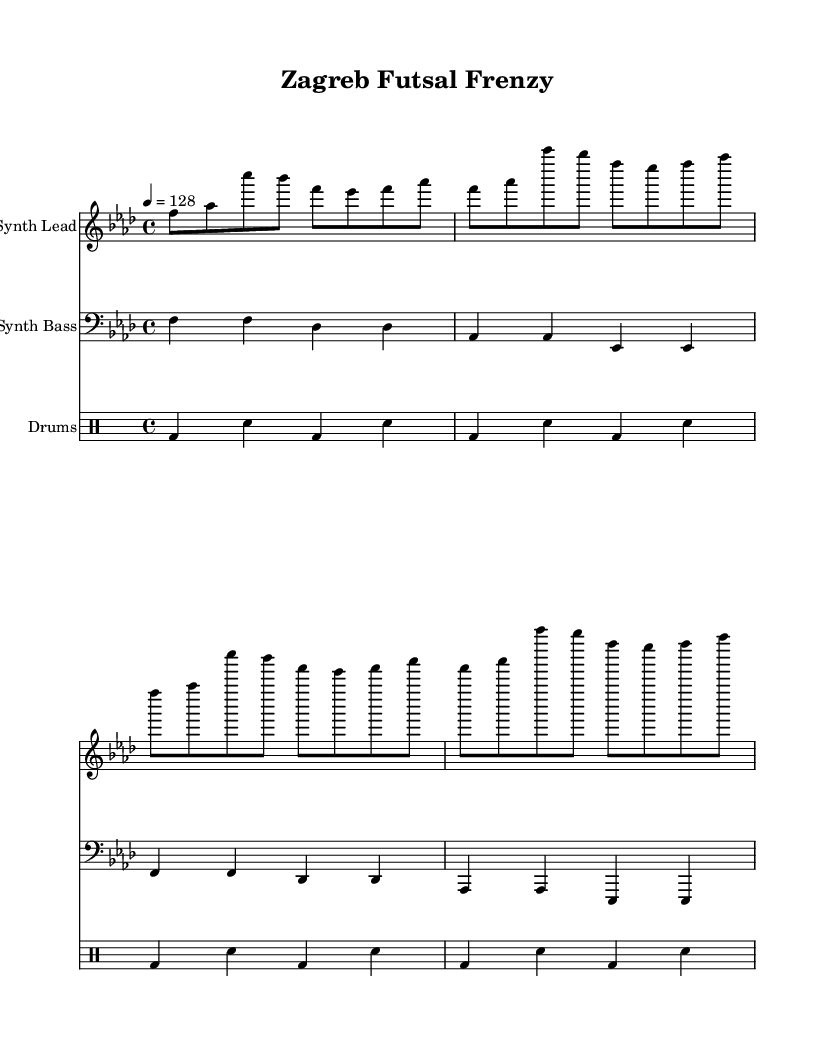What is the key signature of this music? The key signature indicated in the music is F minor, which is shown by the presence of four flats (B♭, E♭, A♭, and D♭) in the signature at the beginning of the staff.
Answer: F minor What is the time signature of this piece? The time signature shown in the music is 4/4, which indicates that there are four beats per measure and a quarter note receives one beat. This is present at the beginning of the score.
Answer: 4/4 What is the tempo marking for this music? The tempo marking is given as "4 = 128" which indicates that the quarter note is to be played at a speed of 128 beats per minute. This is indicated at the beginning of the score beneath the time signature.
Answer: 128 How many measures are in the synth lead part? By examining the synth lead part, we can count a total of 8 measures which are clearly segmented by vertical bars. This can be verified by observing the repetitive pattern that spans over four repetitions of two measures each.
Answer: 8 What type of music is this piece? This piece is a high-energy electronic dance music piece, as indicated by its rhythmic drive, synthesizer usage, and upbeat nature which is often characteristic of EDM, ideal for pre-game warm-ups.
Answer: Electronic Dance Music What is the name of this composition? The title indicated at the top of the sheet music is "Zagreb Futsal Frenzy," which is a clear indication of its intended theme and purpose, related to futsal enthusiasm.
Answer: Zagreb Futsal Frenzy 